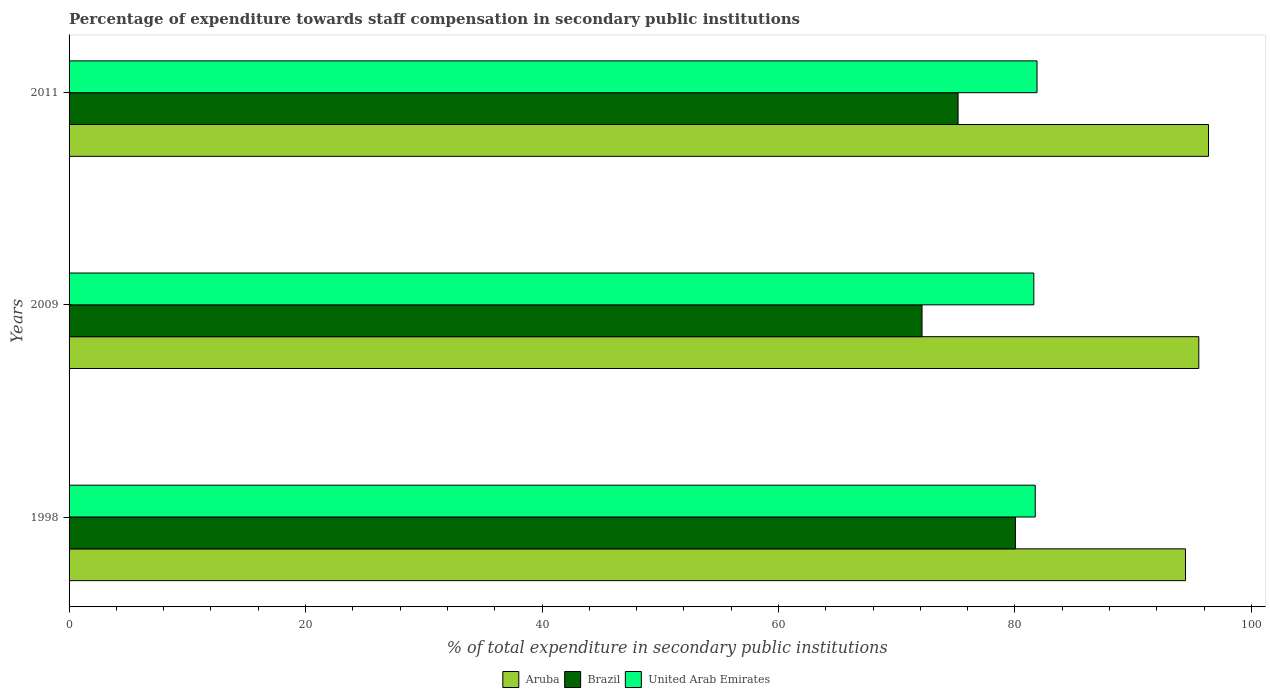Are the number of bars per tick equal to the number of legend labels?
Make the answer very short. Yes. How many bars are there on the 1st tick from the top?
Give a very brief answer. 3. What is the label of the 2nd group of bars from the top?
Make the answer very short. 2009. In how many cases, is the number of bars for a given year not equal to the number of legend labels?
Provide a short and direct response. 0. What is the percentage of expenditure towards staff compensation in United Arab Emirates in 1998?
Give a very brief answer. 81.72. Across all years, what is the maximum percentage of expenditure towards staff compensation in Aruba?
Make the answer very short. 96.37. Across all years, what is the minimum percentage of expenditure towards staff compensation in Aruba?
Offer a terse response. 94.42. In which year was the percentage of expenditure towards staff compensation in Brazil minimum?
Your answer should be compact. 2009. What is the total percentage of expenditure towards staff compensation in Brazil in the graph?
Your answer should be very brief. 227.37. What is the difference between the percentage of expenditure towards staff compensation in Aruba in 1998 and that in 2011?
Offer a terse response. -1.95. What is the difference between the percentage of expenditure towards staff compensation in United Arab Emirates in 2009 and the percentage of expenditure towards staff compensation in Brazil in 2011?
Your answer should be compact. 6.41. What is the average percentage of expenditure towards staff compensation in Aruba per year?
Make the answer very short. 95.45. In the year 2009, what is the difference between the percentage of expenditure towards staff compensation in United Arab Emirates and percentage of expenditure towards staff compensation in Aruba?
Ensure brevity in your answer.  -13.96. In how many years, is the percentage of expenditure towards staff compensation in United Arab Emirates greater than 28 %?
Keep it short and to the point. 3. What is the ratio of the percentage of expenditure towards staff compensation in United Arab Emirates in 1998 to that in 2011?
Make the answer very short. 1. Is the percentage of expenditure towards staff compensation in Aruba in 1998 less than that in 2009?
Offer a very short reply. Yes. What is the difference between the highest and the second highest percentage of expenditure towards staff compensation in United Arab Emirates?
Provide a succinct answer. 0.15. What is the difference between the highest and the lowest percentage of expenditure towards staff compensation in Brazil?
Ensure brevity in your answer.  7.9. What does the 1st bar from the top in 1998 represents?
Provide a succinct answer. United Arab Emirates. What does the 3rd bar from the bottom in 2009 represents?
Provide a short and direct response. United Arab Emirates. Is it the case that in every year, the sum of the percentage of expenditure towards staff compensation in Brazil and percentage of expenditure towards staff compensation in United Arab Emirates is greater than the percentage of expenditure towards staff compensation in Aruba?
Your answer should be compact. Yes. How many bars are there?
Your answer should be compact. 9. Are all the bars in the graph horizontal?
Give a very brief answer. Yes. How many years are there in the graph?
Give a very brief answer. 3. How many legend labels are there?
Make the answer very short. 3. What is the title of the graph?
Offer a terse response. Percentage of expenditure towards staff compensation in secondary public institutions. What is the label or title of the X-axis?
Make the answer very short. % of total expenditure in secondary public institutions. What is the % of total expenditure in secondary public institutions of Aruba in 1998?
Provide a succinct answer. 94.42. What is the % of total expenditure in secondary public institutions of Brazil in 1998?
Make the answer very short. 80.04. What is the % of total expenditure in secondary public institutions in United Arab Emirates in 1998?
Keep it short and to the point. 81.72. What is the % of total expenditure in secondary public institutions of Aruba in 2009?
Offer a terse response. 95.55. What is the % of total expenditure in secondary public institutions of Brazil in 2009?
Offer a terse response. 72.14. What is the % of total expenditure in secondary public institutions in United Arab Emirates in 2009?
Your answer should be compact. 81.6. What is the % of total expenditure in secondary public institutions in Aruba in 2011?
Give a very brief answer. 96.37. What is the % of total expenditure in secondary public institutions of Brazil in 2011?
Provide a succinct answer. 75.19. What is the % of total expenditure in secondary public institutions of United Arab Emirates in 2011?
Your answer should be compact. 81.87. Across all years, what is the maximum % of total expenditure in secondary public institutions in Aruba?
Provide a short and direct response. 96.37. Across all years, what is the maximum % of total expenditure in secondary public institutions of Brazil?
Provide a short and direct response. 80.04. Across all years, what is the maximum % of total expenditure in secondary public institutions of United Arab Emirates?
Offer a terse response. 81.87. Across all years, what is the minimum % of total expenditure in secondary public institutions in Aruba?
Offer a very short reply. 94.42. Across all years, what is the minimum % of total expenditure in secondary public institutions in Brazil?
Provide a succinct answer. 72.14. Across all years, what is the minimum % of total expenditure in secondary public institutions in United Arab Emirates?
Your answer should be compact. 81.6. What is the total % of total expenditure in secondary public institutions of Aruba in the graph?
Make the answer very short. 286.35. What is the total % of total expenditure in secondary public institutions of Brazil in the graph?
Give a very brief answer. 227.37. What is the total % of total expenditure in secondary public institutions in United Arab Emirates in the graph?
Your response must be concise. 245.18. What is the difference between the % of total expenditure in secondary public institutions in Aruba in 1998 and that in 2009?
Make the answer very short. -1.13. What is the difference between the % of total expenditure in secondary public institutions of Brazil in 1998 and that in 2009?
Provide a succinct answer. 7.9. What is the difference between the % of total expenditure in secondary public institutions in United Arab Emirates in 1998 and that in 2009?
Your response must be concise. 0.12. What is the difference between the % of total expenditure in secondary public institutions of Aruba in 1998 and that in 2011?
Offer a very short reply. -1.95. What is the difference between the % of total expenditure in secondary public institutions of Brazil in 1998 and that in 2011?
Offer a very short reply. 4.85. What is the difference between the % of total expenditure in secondary public institutions in United Arab Emirates in 1998 and that in 2011?
Offer a very short reply. -0.15. What is the difference between the % of total expenditure in secondary public institutions of Aruba in 2009 and that in 2011?
Keep it short and to the point. -0.82. What is the difference between the % of total expenditure in secondary public institutions in Brazil in 2009 and that in 2011?
Your response must be concise. -3.05. What is the difference between the % of total expenditure in secondary public institutions of United Arab Emirates in 2009 and that in 2011?
Provide a short and direct response. -0.27. What is the difference between the % of total expenditure in secondary public institutions in Aruba in 1998 and the % of total expenditure in secondary public institutions in Brazil in 2009?
Offer a very short reply. 22.28. What is the difference between the % of total expenditure in secondary public institutions in Aruba in 1998 and the % of total expenditure in secondary public institutions in United Arab Emirates in 2009?
Your answer should be very brief. 12.83. What is the difference between the % of total expenditure in secondary public institutions in Brazil in 1998 and the % of total expenditure in secondary public institutions in United Arab Emirates in 2009?
Offer a very short reply. -1.56. What is the difference between the % of total expenditure in secondary public institutions of Aruba in 1998 and the % of total expenditure in secondary public institutions of Brazil in 2011?
Make the answer very short. 19.23. What is the difference between the % of total expenditure in secondary public institutions in Aruba in 1998 and the % of total expenditure in secondary public institutions in United Arab Emirates in 2011?
Offer a terse response. 12.56. What is the difference between the % of total expenditure in secondary public institutions of Brazil in 1998 and the % of total expenditure in secondary public institutions of United Arab Emirates in 2011?
Your answer should be very brief. -1.83. What is the difference between the % of total expenditure in secondary public institutions of Aruba in 2009 and the % of total expenditure in secondary public institutions of Brazil in 2011?
Your answer should be compact. 20.36. What is the difference between the % of total expenditure in secondary public institutions in Aruba in 2009 and the % of total expenditure in secondary public institutions in United Arab Emirates in 2011?
Offer a very short reply. 13.68. What is the difference between the % of total expenditure in secondary public institutions in Brazil in 2009 and the % of total expenditure in secondary public institutions in United Arab Emirates in 2011?
Provide a short and direct response. -9.73. What is the average % of total expenditure in secondary public institutions of Aruba per year?
Offer a very short reply. 95.45. What is the average % of total expenditure in secondary public institutions of Brazil per year?
Your answer should be compact. 75.79. What is the average % of total expenditure in secondary public institutions of United Arab Emirates per year?
Provide a short and direct response. 81.73. In the year 1998, what is the difference between the % of total expenditure in secondary public institutions of Aruba and % of total expenditure in secondary public institutions of Brazil?
Offer a terse response. 14.38. In the year 1998, what is the difference between the % of total expenditure in secondary public institutions of Aruba and % of total expenditure in secondary public institutions of United Arab Emirates?
Your answer should be very brief. 12.71. In the year 1998, what is the difference between the % of total expenditure in secondary public institutions of Brazil and % of total expenditure in secondary public institutions of United Arab Emirates?
Your answer should be compact. -1.68. In the year 2009, what is the difference between the % of total expenditure in secondary public institutions in Aruba and % of total expenditure in secondary public institutions in Brazil?
Provide a succinct answer. 23.41. In the year 2009, what is the difference between the % of total expenditure in secondary public institutions of Aruba and % of total expenditure in secondary public institutions of United Arab Emirates?
Ensure brevity in your answer.  13.96. In the year 2009, what is the difference between the % of total expenditure in secondary public institutions in Brazil and % of total expenditure in secondary public institutions in United Arab Emirates?
Offer a very short reply. -9.45. In the year 2011, what is the difference between the % of total expenditure in secondary public institutions in Aruba and % of total expenditure in secondary public institutions in Brazil?
Ensure brevity in your answer.  21.18. In the year 2011, what is the difference between the % of total expenditure in secondary public institutions of Aruba and % of total expenditure in secondary public institutions of United Arab Emirates?
Your response must be concise. 14.51. In the year 2011, what is the difference between the % of total expenditure in secondary public institutions of Brazil and % of total expenditure in secondary public institutions of United Arab Emirates?
Provide a short and direct response. -6.68. What is the ratio of the % of total expenditure in secondary public institutions of Brazil in 1998 to that in 2009?
Your answer should be compact. 1.11. What is the ratio of the % of total expenditure in secondary public institutions of United Arab Emirates in 1998 to that in 2009?
Your answer should be compact. 1. What is the ratio of the % of total expenditure in secondary public institutions in Aruba in 1998 to that in 2011?
Offer a terse response. 0.98. What is the ratio of the % of total expenditure in secondary public institutions in Brazil in 1998 to that in 2011?
Offer a very short reply. 1.06. What is the ratio of the % of total expenditure in secondary public institutions of United Arab Emirates in 1998 to that in 2011?
Ensure brevity in your answer.  1. What is the ratio of the % of total expenditure in secondary public institutions in Aruba in 2009 to that in 2011?
Ensure brevity in your answer.  0.99. What is the ratio of the % of total expenditure in secondary public institutions in Brazil in 2009 to that in 2011?
Your answer should be compact. 0.96. What is the ratio of the % of total expenditure in secondary public institutions of United Arab Emirates in 2009 to that in 2011?
Provide a short and direct response. 1. What is the difference between the highest and the second highest % of total expenditure in secondary public institutions of Aruba?
Make the answer very short. 0.82. What is the difference between the highest and the second highest % of total expenditure in secondary public institutions of Brazil?
Provide a succinct answer. 4.85. What is the difference between the highest and the second highest % of total expenditure in secondary public institutions of United Arab Emirates?
Your answer should be compact. 0.15. What is the difference between the highest and the lowest % of total expenditure in secondary public institutions in Aruba?
Your answer should be compact. 1.95. What is the difference between the highest and the lowest % of total expenditure in secondary public institutions of Brazil?
Keep it short and to the point. 7.9. What is the difference between the highest and the lowest % of total expenditure in secondary public institutions in United Arab Emirates?
Provide a short and direct response. 0.27. 